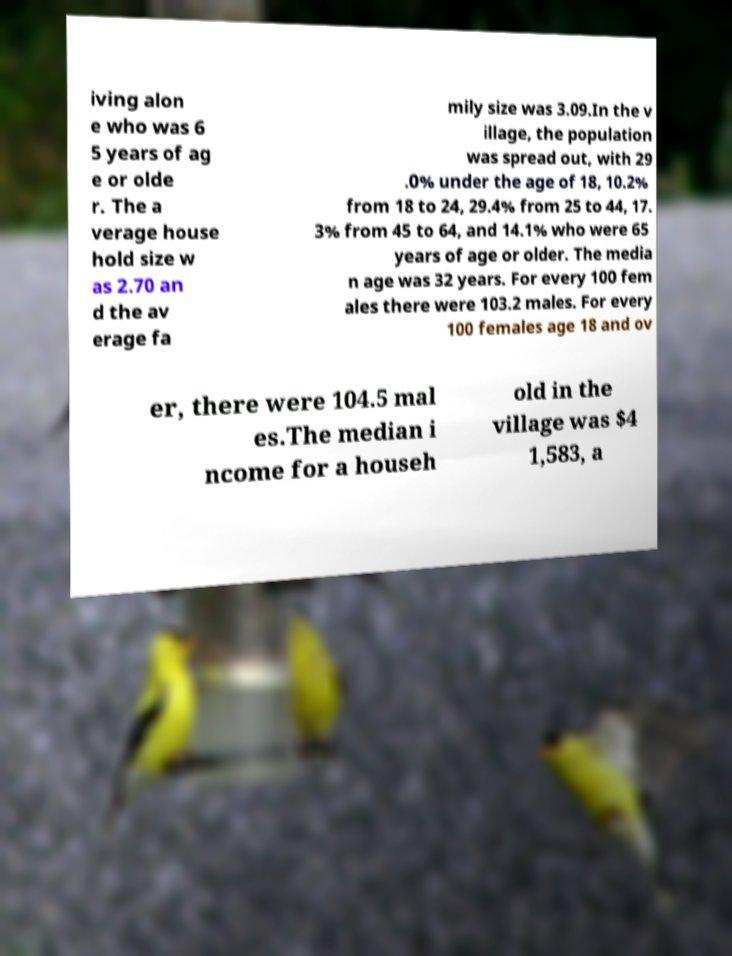Can you read and provide the text displayed in the image?This photo seems to have some interesting text. Can you extract and type it out for me? iving alon e who was 6 5 years of ag e or olde r. The a verage house hold size w as 2.70 an d the av erage fa mily size was 3.09.In the v illage, the population was spread out, with 29 .0% under the age of 18, 10.2% from 18 to 24, 29.4% from 25 to 44, 17. 3% from 45 to 64, and 14.1% who were 65 years of age or older. The media n age was 32 years. For every 100 fem ales there were 103.2 males. For every 100 females age 18 and ov er, there were 104.5 mal es.The median i ncome for a househ old in the village was $4 1,583, a 